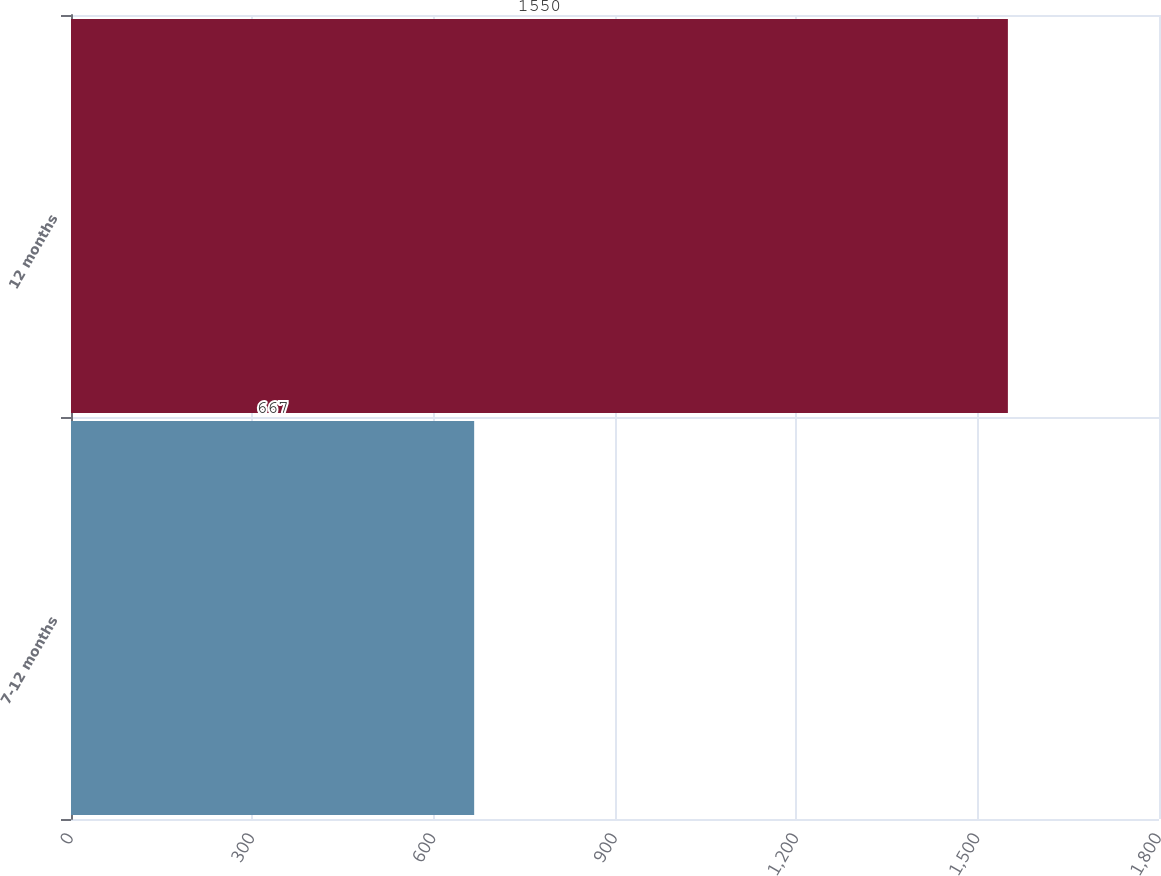<chart> <loc_0><loc_0><loc_500><loc_500><bar_chart><fcel>7-12 months<fcel>12 months<nl><fcel>667<fcel>1550<nl></chart> 